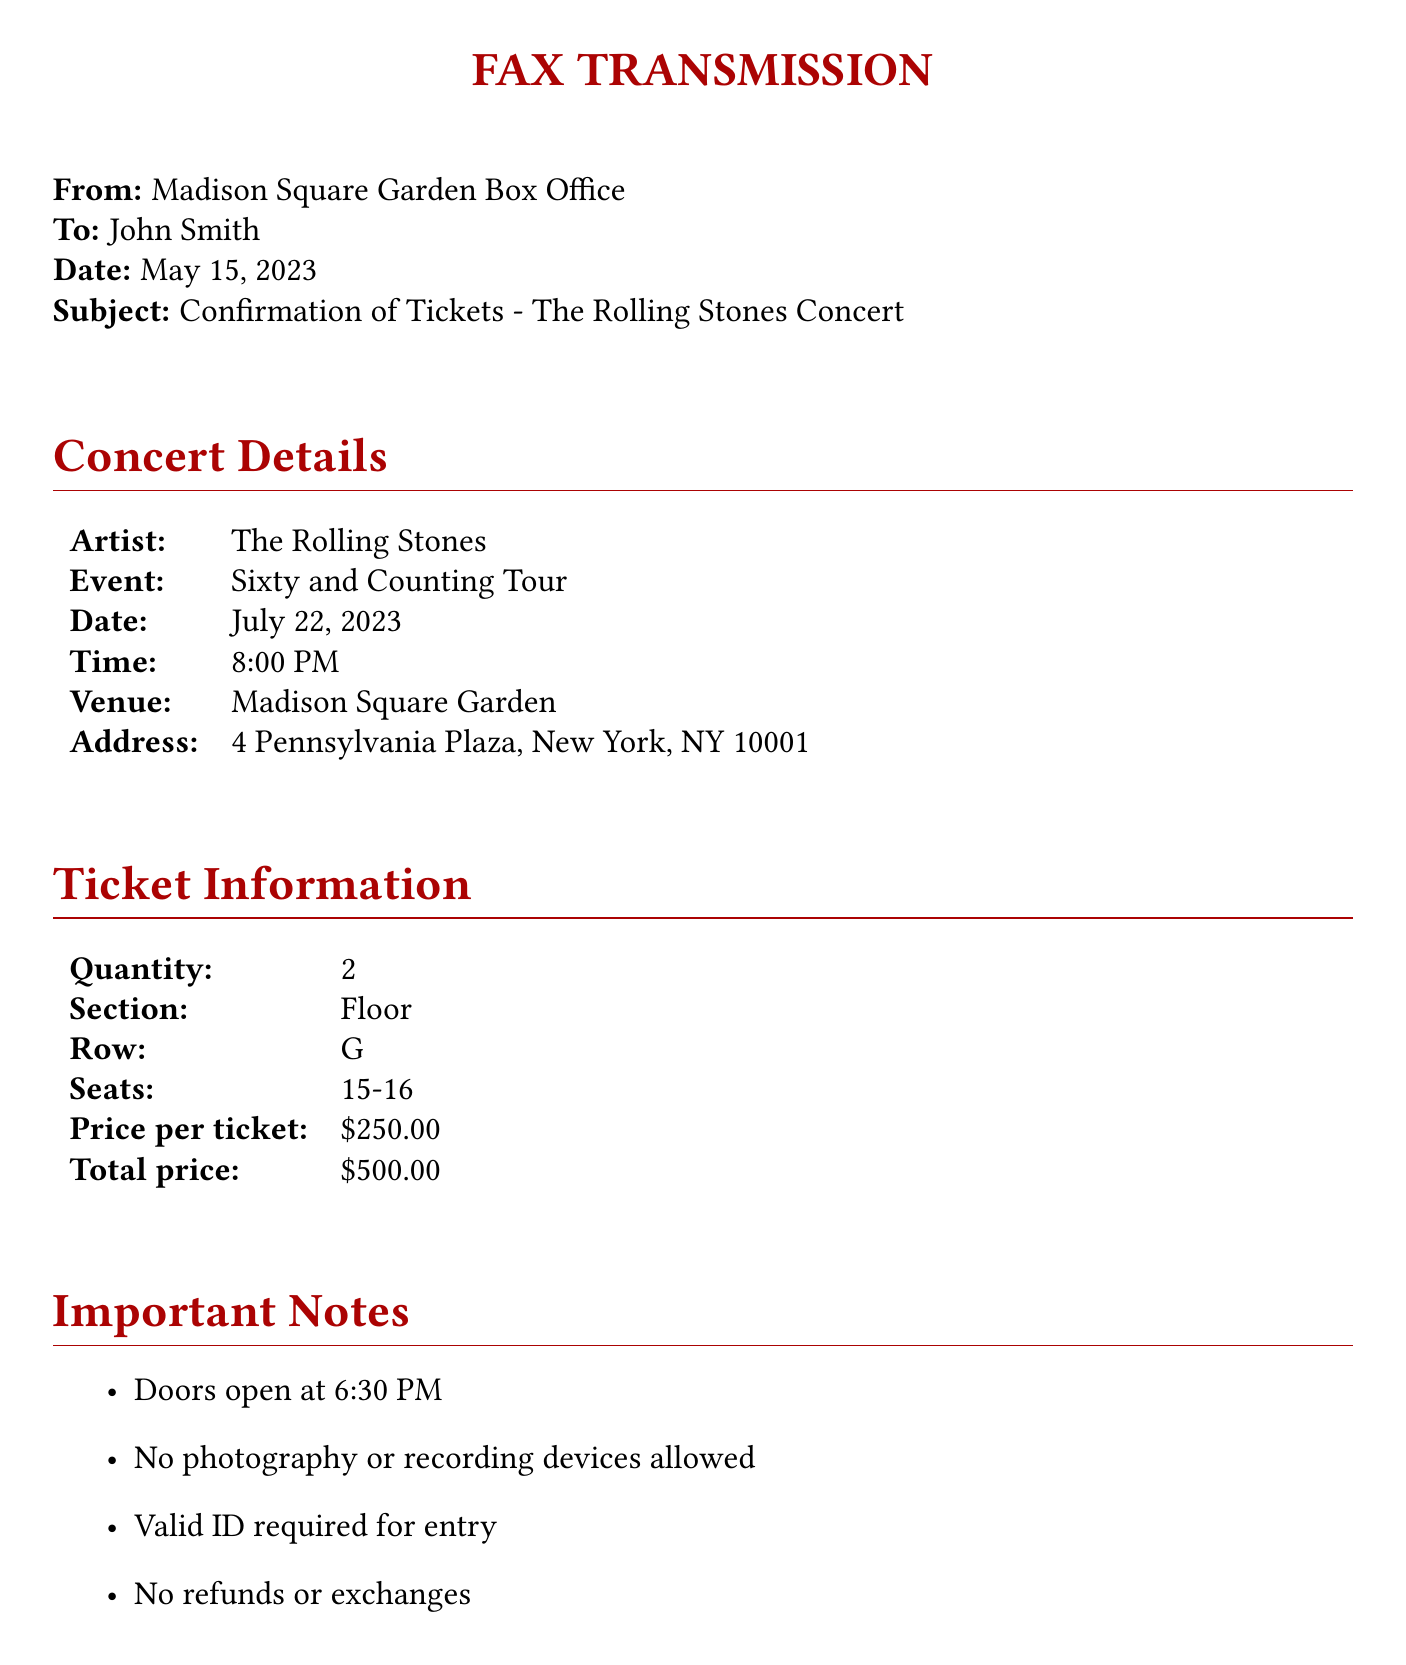what is the artist performing? The artist performing at the concert is The Rolling Stones.
Answer: The Rolling Stones when is the concert date? The concert is scheduled for July 22, 2023.
Answer: July 22, 2023 how many tickets were purchased? The document states that 2 tickets were purchased.
Answer: 2 what section are the seats located in? The seats are located in the Floor section.
Answer: Floor what is the total price of the tickets? The total price for the tickets is stated in the document as $500.00.
Answer: $500.00 what time do the doors open? The doors open at 6:30 PM as mentioned in the document.
Answer: 6:30 PM what is required for entry to the concert? A valid ID is required for entry to the concert.
Answer: Valid ID where should the tickets be picked up? Tickets should be picked up at the Will Call window on the day of the event.
Answer: Will Call window who is the contact for ticket inquiries? The contact number provided for inquiries is (212) 465-6741.
Answer: (212) 465-6741 what is the email address for the box office? The document provides the email address as boxoffice@msg.com.
Answer: boxoffice@msg.com 